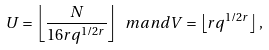<formula> <loc_0><loc_0><loc_500><loc_500>U = \left \lfloor \frac { N } { 1 6 r q ^ { 1 / 2 r } } \right \rfloor \ m a n d V = \left \lfloor r q ^ { 1 / 2 r } \right \rfloor ,</formula> 